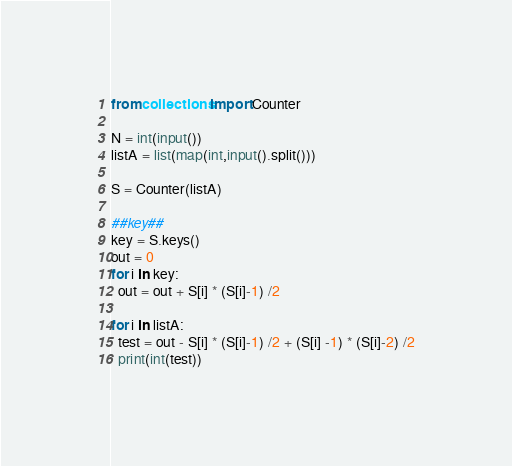Convert code to text. <code><loc_0><loc_0><loc_500><loc_500><_Python_>from collections import Counter

N = int(input())
listA = list(map(int,input().split()))

S = Counter(listA)

##key##
key = S.keys()
out = 0
for i in key:
  out = out + S[i] * (S[i]-1) /2

for i in listA:
  test = out - S[i] * (S[i]-1) /2 + (S[i] -1) * (S[i]-2) /2
  print(int(test))</code> 